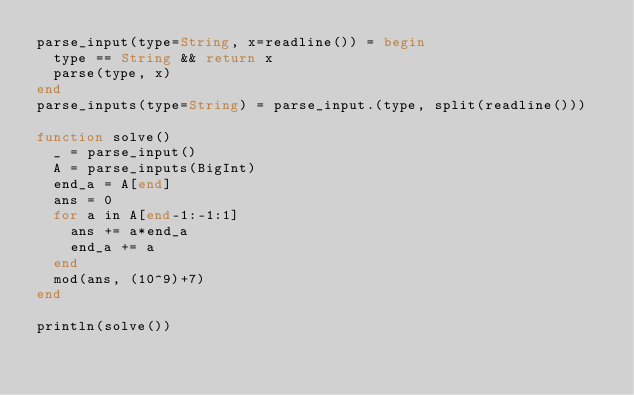Convert code to text. <code><loc_0><loc_0><loc_500><loc_500><_Julia_>parse_input(type=String, x=readline()) = begin
  type == String && return x
  parse(type, x)
end
parse_inputs(type=String) = parse_input.(type, split(readline()))

function solve()
  _ = parse_input()
  A = parse_inputs(BigInt)
  end_a = A[end]
  ans = 0
  for a in A[end-1:-1:1]
    ans += a*end_a
    end_a += a
  end
  mod(ans, (10^9)+7)
end

println(solve())
</code> 